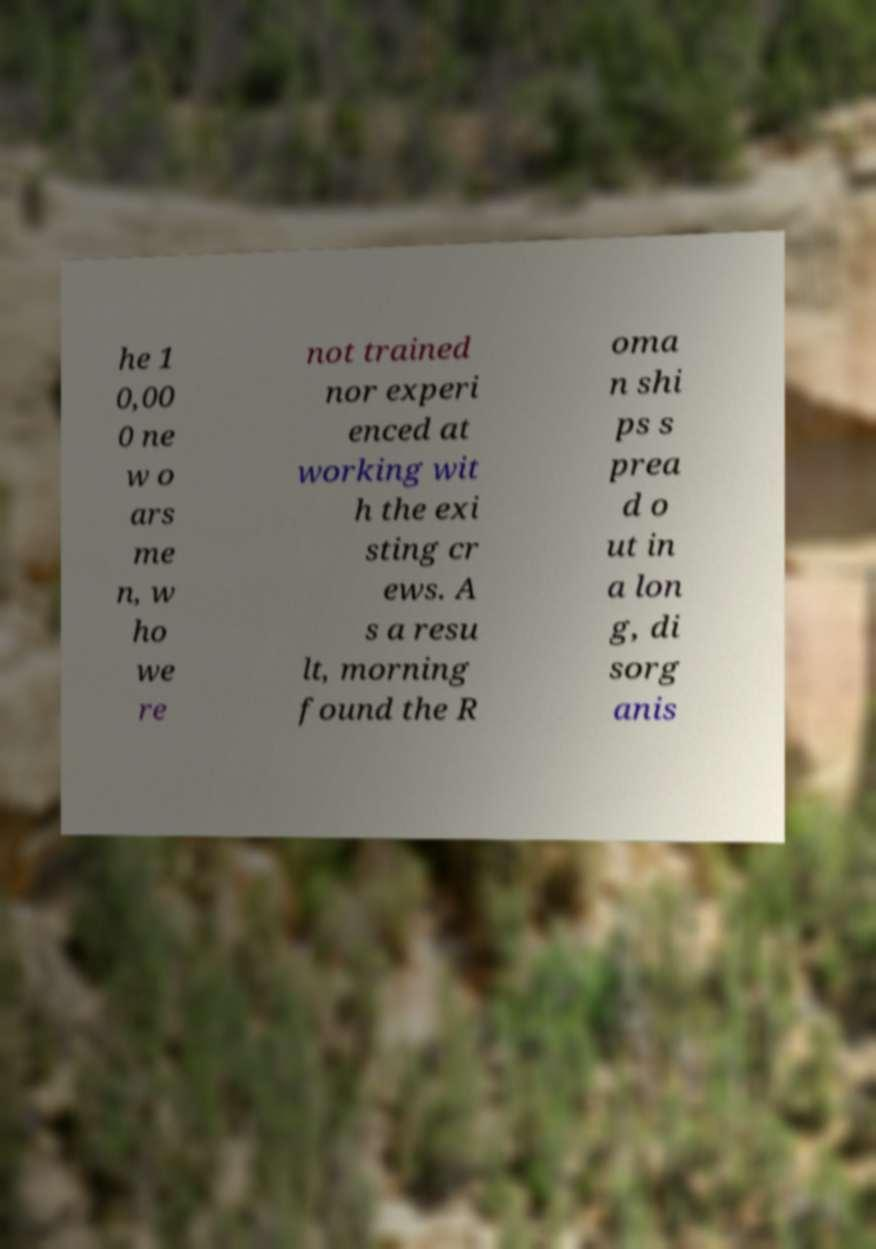For documentation purposes, I need the text within this image transcribed. Could you provide that? he 1 0,00 0 ne w o ars me n, w ho we re not trained nor experi enced at working wit h the exi sting cr ews. A s a resu lt, morning found the R oma n shi ps s prea d o ut in a lon g, di sorg anis 